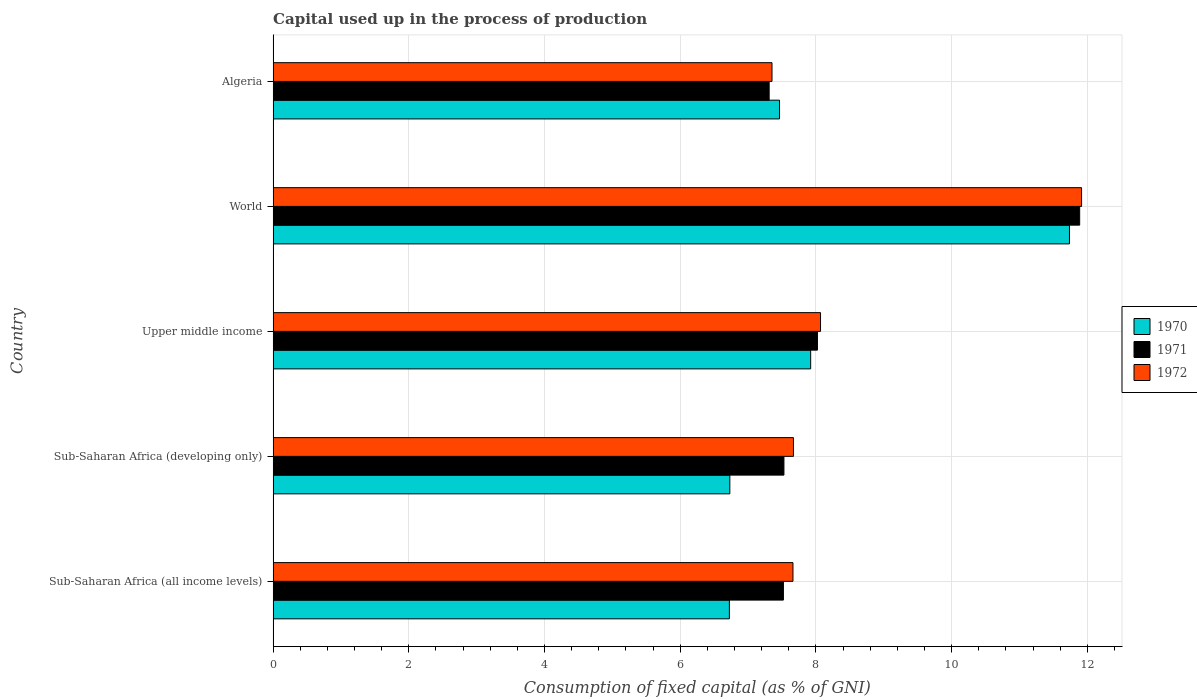How many different coloured bars are there?
Provide a short and direct response. 3. Are the number of bars on each tick of the Y-axis equal?
Your answer should be very brief. Yes. What is the label of the 5th group of bars from the top?
Keep it short and to the point. Sub-Saharan Africa (all income levels). In how many cases, is the number of bars for a given country not equal to the number of legend labels?
Your answer should be very brief. 0. What is the capital used up in the process of production in 1972 in Upper middle income?
Ensure brevity in your answer.  8.07. Across all countries, what is the maximum capital used up in the process of production in 1972?
Your response must be concise. 11.92. Across all countries, what is the minimum capital used up in the process of production in 1972?
Your response must be concise. 7.35. In which country was the capital used up in the process of production in 1970 maximum?
Offer a terse response. World. In which country was the capital used up in the process of production in 1972 minimum?
Your answer should be very brief. Algeria. What is the total capital used up in the process of production in 1972 in the graph?
Offer a terse response. 42.67. What is the difference between the capital used up in the process of production in 1971 in Sub-Saharan Africa (developing only) and that in World?
Your response must be concise. -4.36. What is the difference between the capital used up in the process of production in 1970 in Upper middle income and the capital used up in the process of production in 1971 in Sub-Saharan Africa (developing only)?
Give a very brief answer. 0.39. What is the average capital used up in the process of production in 1970 per country?
Your answer should be compact. 8.12. What is the difference between the capital used up in the process of production in 1970 and capital used up in the process of production in 1971 in Algeria?
Your response must be concise. 0.15. What is the ratio of the capital used up in the process of production in 1970 in Sub-Saharan Africa (all income levels) to that in World?
Ensure brevity in your answer.  0.57. Is the difference between the capital used up in the process of production in 1970 in Upper middle income and World greater than the difference between the capital used up in the process of production in 1971 in Upper middle income and World?
Offer a very short reply. Yes. What is the difference between the highest and the second highest capital used up in the process of production in 1971?
Give a very brief answer. 3.86. What is the difference between the highest and the lowest capital used up in the process of production in 1971?
Give a very brief answer. 4.58. Is the sum of the capital used up in the process of production in 1971 in Sub-Saharan Africa (all income levels) and World greater than the maximum capital used up in the process of production in 1972 across all countries?
Your answer should be very brief. Yes. What does the 2nd bar from the top in Upper middle income represents?
Provide a succinct answer. 1971. Does the graph contain grids?
Make the answer very short. Yes. How are the legend labels stacked?
Your answer should be very brief. Vertical. What is the title of the graph?
Give a very brief answer. Capital used up in the process of production. Does "1984" appear as one of the legend labels in the graph?
Your answer should be very brief. No. What is the label or title of the X-axis?
Ensure brevity in your answer.  Consumption of fixed capital (as % of GNI). What is the label or title of the Y-axis?
Make the answer very short. Country. What is the Consumption of fixed capital (as % of GNI) of 1970 in Sub-Saharan Africa (all income levels)?
Provide a short and direct response. 6.72. What is the Consumption of fixed capital (as % of GNI) in 1971 in Sub-Saharan Africa (all income levels)?
Provide a short and direct response. 7.52. What is the Consumption of fixed capital (as % of GNI) of 1972 in Sub-Saharan Africa (all income levels)?
Give a very brief answer. 7.66. What is the Consumption of fixed capital (as % of GNI) in 1970 in Sub-Saharan Africa (developing only)?
Make the answer very short. 6.73. What is the Consumption of fixed capital (as % of GNI) of 1971 in Sub-Saharan Africa (developing only)?
Your response must be concise. 7.53. What is the Consumption of fixed capital (as % of GNI) of 1972 in Sub-Saharan Africa (developing only)?
Provide a short and direct response. 7.67. What is the Consumption of fixed capital (as % of GNI) in 1970 in Upper middle income?
Provide a succinct answer. 7.92. What is the Consumption of fixed capital (as % of GNI) of 1971 in Upper middle income?
Your response must be concise. 8.02. What is the Consumption of fixed capital (as % of GNI) of 1972 in Upper middle income?
Your answer should be compact. 8.07. What is the Consumption of fixed capital (as % of GNI) in 1970 in World?
Provide a succinct answer. 11.74. What is the Consumption of fixed capital (as % of GNI) in 1971 in World?
Provide a succinct answer. 11.89. What is the Consumption of fixed capital (as % of GNI) of 1972 in World?
Ensure brevity in your answer.  11.92. What is the Consumption of fixed capital (as % of GNI) of 1970 in Algeria?
Offer a terse response. 7.46. What is the Consumption of fixed capital (as % of GNI) in 1971 in Algeria?
Offer a very short reply. 7.31. What is the Consumption of fixed capital (as % of GNI) in 1972 in Algeria?
Make the answer very short. 7.35. Across all countries, what is the maximum Consumption of fixed capital (as % of GNI) in 1970?
Provide a succinct answer. 11.74. Across all countries, what is the maximum Consumption of fixed capital (as % of GNI) of 1971?
Offer a terse response. 11.89. Across all countries, what is the maximum Consumption of fixed capital (as % of GNI) of 1972?
Provide a succinct answer. 11.92. Across all countries, what is the minimum Consumption of fixed capital (as % of GNI) in 1970?
Your answer should be very brief. 6.72. Across all countries, what is the minimum Consumption of fixed capital (as % of GNI) in 1971?
Make the answer very short. 7.31. Across all countries, what is the minimum Consumption of fixed capital (as % of GNI) of 1972?
Provide a short and direct response. 7.35. What is the total Consumption of fixed capital (as % of GNI) of 1970 in the graph?
Provide a succinct answer. 40.58. What is the total Consumption of fixed capital (as % of GNI) in 1971 in the graph?
Offer a very short reply. 42.27. What is the total Consumption of fixed capital (as % of GNI) in 1972 in the graph?
Give a very brief answer. 42.67. What is the difference between the Consumption of fixed capital (as % of GNI) of 1970 in Sub-Saharan Africa (all income levels) and that in Sub-Saharan Africa (developing only)?
Your response must be concise. -0.01. What is the difference between the Consumption of fixed capital (as % of GNI) of 1971 in Sub-Saharan Africa (all income levels) and that in Sub-Saharan Africa (developing only)?
Offer a terse response. -0.01. What is the difference between the Consumption of fixed capital (as % of GNI) of 1972 in Sub-Saharan Africa (all income levels) and that in Sub-Saharan Africa (developing only)?
Offer a terse response. -0.01. What is the difference between the Consumption of fixed capital (as % of GNI) of 1970 in Sub-Saharan Africa (all income levels) and that in Upper middle income?
Keep it short and to the point. -1.2. What is the difference between the Consumption of fixed capital (as % of GNI) in 1971 in Sub-Saharan Africa (all income levels) and that in Upper middle income?
Your answer should be very brief. -0.5. What is the difference between the Consumption of fixed capital (as % of GNI) of 1972 in Sub-Saharan Africa (all income levels) and that in Upper middle income?
Provide a succinct answer. -0.41. What is the difference between the Consumption of fixed capital (as % of GNI) in 1970 in Sub-Saharan Africa (all income levels) and that in World?
Give a very brief answer. -5.01. What is the difference between the Consumption of fixed capital (as % of GNI) of 1971 in Sub-Saharan Africa (all income levels) and that in World?
Offer a terse response. -4.37. What is the difference between the Consumption of fixed capital (as % of GNI) of 1972 in Sub-Saharan Africa (all income levels) and that in World?
Ensure brevity in your answer.  -4.25. What is the difference between the Consumption of fixed capital (as % of GNI) in 1970 in Sub-Saharan Africa (all income levels) and that in Algeria?
Offer a very short reply. -0.74. What is the difference between the Consumption of fixed capital (as % of GNI) in 1971 in Sub-Saharan Africa (all income levels) and that in Algeria?
Your answer should be compact. 0.21. What is the difference between the Consumption of fixed capital (as % of GNI) of 1972 in Sub-Saharan Africa (all income levels) and that in Algeria?
Ensure brevity in your answer.  0.31. What is the difference between the Consumption of fixed capital (as % of GNI) of 1970 in Sub-Saharan Africa (developing only) and that in Upper middle income?
Provide a short and direct response. -1.19. What is the difference between the Consumption of fixed capital (as % of GNI) of 1971 in Sub-Saharan Africa (developing only) and that in Upper middle income?
Your answer should be compact. -0.49. What is the difference between the Consumption of fixed capital (as % of GNI) in 1972 in Sub-Saharan Africa (developing only) and that in Upper middle income?
Your response must be concise. -0.4. What is the difference between the Consumption of fixed capital (as % of GNI) of 1970 in Sub-Saharan Africa (developing only) and that in World?
Your answer should be very brief. -5.01. What is the difference between the Consumption of fixed capital (as % of GNI) in 1971 in Sub-Saharan Africa (developing only) and that in World?
Your answer should be compact. -4.36. What is the difference between the Consumption of fixed capital (as % of GNI) of 1972 in Sub-Saharan Africa (developing only) and that in World?
Your answer should be very brief. -4.25. What is the difference between the Consumption of fixed capital (as % of GNI) in 1970 in Sub-Saharan Africa (developing only) and that in Algeria?
Offer a terse response. -0.73. What is the difference between the Consumption of fixed capital (as % of GNI) of 1971 in Sub-Saharan Africa (developing only) and that in Algeria?
Ensure brevity in your answer.  0.22. What is the difference between the Consumption of fixed capital (as % of GNI) in 1972 in Sub-Saharan Africa (developing only) and that in Algeria?
Make the answer very short. 0.32. What is the difference between the Consumption of fixed capital (as % of GNI) of 1970 in Upper middle income and that in World?
Your answer should be very brief. -3.81. What is the difference between the Consumption of fixed capital (as % of GNI) of 1971 in Upper middle income and that in World?
Provide a short and direct response. -3.86. What is the difference between the Consumption of fixed capital (as % of GNI) of 1972 in Upper middle income and that in World?
Your response must be concise. -3.85. What is the difference between the Consumption of fixed capital (as % of GNI) in 1970 in Upper middle income and that in Algeria?
Ensure brevity in your answer.  0.46. What is the difference between the Consumption of fixed capital (as % of GNI) in 1971 in Upper middle income and that in Algeria?
Offer a very short reply. 0.71. What is the difference between the Consumption of fixed capital (as % of GNI) in 1972 in Upper middle income and that in Algeria?
Your response must be concise. 0.72. What is the difference between the Consumption of fixed capital (as % of GNI) in 1970 in World and that in Algeria?
Your answer should be compact. 4.27. What is the difference between the Consumption of fixed capital (as % of GNI) of 1971 in World and that in Algeria?
Provide a short and direct response. 4.58. What is the difference between the Consumption of fixed capital (as % of GNI) of 1972 in World and that in Algeria?
Offer a terse response. 4.56. What is the difference between the Consumption of fixed capital (as % of GNI) in 1970 in Sub-Saharan Africa (all income levels) and the Consumption of fixed capital (as % of GNI) in 1971 in Sub-Saharan Africa (developing only)?
Provide a succinct answer. -0.8. What is the difference between the Consumption of fixed capital (as % of GNI) in 1970 in Sub-Saharan Africa (all income levels) and the Consumption of fixed capital (as % of GNI) in 1972 in Sub-Saharan Africa (developing only)?
Your answer should be very brief. -0.94. What is the difference between the Consumption of fixed capital (as % of GNI) in 1971 in Sub-Saharan Africa (all income levels) and the Consumption of fixed capital (as % of GNI) in 1972 in Sub-Saharan Africa (developing only)?
Give a very brief answer. -0.15. What is the difference between the Consumption of fixed capital (as % of GNI) of 1970 in Sub-Saharan Africa (all income levels) and the Consumption of fixed capital (as % of GNI) of 1971 in Upper middle income?
Make the answer very short. -1.3. What is the difference between the Consumption of fixed capital (as % of GNI) in 1970 in Sub-Saharan Africa (all income levels) and the Consumption of fixed capital (as % of GNI) in 1972 in Upper middle income?
Offer a terse response. -1.34. What is the difference between the Consumption of fixed capital (as % of GNI) in 1971 in Sub-Saharan Africa (all income levels) and the Consumption of fixed capital (as % of GNI) in 1972 in Upper middle income?
Ensure brevity in your answer.  -0.55. What is the difference between the Consumption of fixed capital (as % of GNI) in 1970 in Sub-Saharan Africa (all income levels) and the Consumption of fixed capital (as % of GNI) in 1971 in World?
Offer a terse response. -5.16. What is the difference between the Consumption of fixed capital (as % of GNI) of 1970 in Sub-Saharan Africa (all income levels) and the Consumption of fixed capital (as % of GNI) of 1972 in World?
Give a very brief answer. -5.19. What is the difference between the Consumption of fixed capital (as % of GNI) of 1971 in Sub-Saharan Africa (all income levels) and the Consumption of fixed capital (as % of GNI) of 1972 in World?
Your answer should be very brief. -4.39. What is the difference between the Consumption of fixed capital (as % of GNI) in 1970 in Sub-Saharan Africa (all income levels) and the Consumption of fixed capital (as % of GNI) in 1971 in Algeria?
Your answer should be very brief. -0.59. What is the difference between the Consumption of fixed capital (as % of GNI) in 1970 in Sub-Saharan Africa (all income levels) and the Consumption of fixed capital (as % of GNI) in 1972 in Algeria?
Ensure brevity in your answer.  -0.63. What is the difference between the Consumption of fixed capital (as % of GNI) of 1971 in Sub-Saharan Africa (all income levels) and the Consumption of fixed capital (as % of GNI) of 1972 in Algeria?
Your answer should be very brief. 0.17. What is the difference between the Consumption of fixed capital (as % of GNI) of 1970 in Sub-Saharan Africa (developing only) and the Consumption of fixed capital (as % of GNI) of 1971 in Upper middle income?
Your answer should be compact. -1.29. What is the difference between the Consumption of fixed capital (as % of GNI) in 1970 in Sub-Saharan Africa (developing only) and the Consumption of fixed capital (as % of GNI) in 1972 in Upper middle income?
Your answer should be compact. -1.34. What is the difference between the Consumption of fixed capital (as % of GNI) of 1971 in Sub-Saharan Africa (developing only) and the Consumption of fixed capital (as % of GNI) of 1972 in Upper middle income?
Provide a succinct answer. -0.54. What is the difference between the Consumption of fixed capital (as % of GNI) of 1970 in Sub-Saharan Africa (developing only) and the Consumption of fixed capital (as % of GNI) of 1971 in World?
Give a very brief answer. -5.16. What is the difference between the Consumption of fixed capital (as % of GNI) of 1970 in Sub-Saharan Africa (developing only) and the Consumption of fixed capital (as % of GNI) of 1972 in World?
Give a very brief answer. -5.18. What is the difference between the Consumption of fixed capital (as % of GNI) in 1971 in Sub-Saharan Africa (developing only) and the Consumption of fixed capital (as % of GNI) in 1972 in World?
Your response must be concise. -4.39. What is the difference between the Consumption of fixed capital (as % of GNI) in 1970 in Sub-Saharan Africa (developing only) and the Consumption of fixed capital (as % of GNI) in 1971 in Algeria?
Your answer should be compact. -0.58. What is the difference between the Consumption of fixed capital (as % of GNI) in 1970 in Sub-Saharan Africa (developing only) and the Consumption of fixed capital (as % of GNI) in 1972 in Algeria?
Keep it short and to the point. -0.62. What is the difference between the Consumption of fixed capital (as % of GNI) of 1971 in Sub-Saharan Africa (developing only) and the Consumption of fixed capital (as % of GNI) of 1972 in Algeria?
Make the answer very short. 0.18. What is the difference between the Consumption of fixed capital (as % of GNI) of 1970 in Upper middle income and the Consumption of fixed capital (as % of GNI) of 1971 in World?
Provide a succinct answer. -3.96. What is the difference between the Consumption of fixed capital (as % of GNI) of 1970 in Upper middle income and the Consumption of fixed capital (as % of GNI) of 1972 in World?
Give a very brief answer. -3.99. What is the difference between the Consumption of fixed capital (as % of GNI) of 1971 in Upper middle income and the Consumption of fixed capital (as % of GNI) of 1972 in World?
Give a very brief answer. -3.89. What is the difference between the Consumption of fixed capital (as % of GNI) of 1970 in Upper middle income and the Consumption of fixed capital (as % of GNI) of 1971 in Algeria?
Ensure brevity in your answer.  0.61. What is the difference between the Consumption of fixed capital (as % of GNI) of 1970 in Upper middle income and the Consumption of fixed capital (as % of GNI) of 1972 in Algeria?
Your response must be concise. 0.57. What is the difference between the Consumption of fixed capital (as % of GNI) of 1971 in Upper middle income and the Consumption of fixed capital (as % of GNI) of 1972 in Algeria?
Give a very brief answer. 0.67. What is the difference between the Consumption of fixed capital (as % of GNI) of 1970 in World and the Consumption of fixed capital (as % of GNI) of 1971 in Algeria?
Make the answer very short. 4.43. What is the difference between the Consumption of fixed capital (as % of GNI) in 1970 in World and the Consumption of fixed capital (as % of GNI) in 1972 in Algeria?
Keep it short and to the point. 4.38. What is the difference between the Consumption of fixed capital (as % of GNI) of 1971 in World and the Consumption of fixed capital (as % of GNI) of 1972 in Algeria?
Give a very brief answer. 4.53. What is the average Consumption of fixed capital (as % of GNI) of 1970 per country?
Make the answer very short. 8.12. What is the average Consumption of fixed capital (as % of GNI) of 1971 per country?
Provide a short and direct response. 8.45. What is the average Consumption of fixed capital (as % of GNI) of 1972 per country?
Provide a succinct answer. 8.53. What is the difference between the Consumption of fixed capital (as % of GNI) of 1970 and Consumption of fixed capital (as % of GNI) of 1971 in Sub-Saharan Africa (all income levels)?
Offer a very short reply. -0.8. What is the difference between the Consumption of fixed capital (as % of GNI) in 1970 and Consumption of fixed capital (as % of GNI) in 1972 in Sub-Saharan Africa (all income levels)?
Provide a succinct answer. -0.94. What is the difference between the Consumption of fixed capital (as % of GNI) of 1971 and Consumption of fixed capital (as % of GNI) of 1972 in Sub-Saharan Africa (all income levels)?
Offer a terse response. -0.14. What is the difference between the Consumption of fixed capital (as % of GNI) of 1970 and Consumption of fixed capital (as % of GNI) of 1971 in Sub-Saharan Africa (developing only)?
Provide a succinct answer. -0.8. What is the difference between the Consumption of fixed capital (as % of GNI) of 1970 and Consumption of fixed capital (as % of GNI) of 1972 in Sub-Saharan Africa (developing only)?
Ensure brevity in your answer.  -0.94. What is the difference between the Consumption of fixed capital (as % of GNI) of 1971 and Consumption of fixed capital (as % of GNI) of 1972 in Sub-Saharan Africa (developing only)?
Offer a terse response. -0.14. What is the difference between the Consumption of fixed capital (as % of GNI) of 1970 and Consumption of fixed capital (as % of GNI) of 1971 in Upper middle income?
Ensure brevity in your answer.  -0.1. What is the difference between the Consumption of fixed capital (as % of GNI) in 1970 and Consumption of fixed capital (as % of GNI) in 1972 in Upper middle income?
Make the answer very short. -0.15. What is the difference between the Consumption of fixed capital (as % of GNI) in 1971 and Consumption of fixed capital (as % of GNI) in 1972 in Upper middle income?
Offer a terse response. -0.05. What is the difference between the Consumption of fixed capital (as % of GNI) in 1970 and Consumption of fixed capital (as % of GNI) in 1971 in World?
Your response must be concise. -0.15. What is the difference between the Consumption of fixed capital (as % of GNI) of 1970 and Consumption of fixed capital (as % of GNI) of 1972 in World?
Ensure brevity in your answer.  -0.18. What is the difference between the Consumption of fixed capital (as % of GNI) of 1971 and Consumption of fixed capital (as % of GNI) of 1972 in World?
Offer a terse response. -0.03. What is the difference between the Consumption of fixed capital (as % of GNI) of 1970 and Consumption of fixed capital (as % of GNI) of 1971 in Algeria?
Your answer should be very brief. 0.15. What is the difference between the Consumption of fixed capital (as % of GNI) in 1971 and Consumption of fixed capital (as % of GNI) in 1972 in Algeria?
Provide a succinct answer. -0.04. What is the ratio of the Consumption of fixed capital (as % of GNI) of 1971 in Sub-Saharan Africa (all income levels) to that in Sub-Saharan Africa (developing only)?
Your response must be concise. 1. What is the ratio of the Consumption of fixed capital (as % of GNI) of 1972 in Sub-Saharan Africa (all income levels) to that in Sub-Saharan Africa (developing only)?
Provide a succinct answer. 1. What is the ratio of the Consumption of fixed capital (as % of GNI) of 1970 in Sub-Saharan Africa (all income levels) to that in Upper middle income?
Offer a terse response. 0.85. What is the ratio of the Consumption of fixed capital (as % of GNI) of 1971 in Sub-Saharan Africa (all income levels) to that in Upper middle income?
Make the answer very short. 0.94. What is the ratio of the Consumption of fixed capital (as % of GNI) in 1972 in Sub-Saharan Africa (all income levels) to that in Upper middle income?
Make the answer very short. 0.95. What is the ratio of the Consumption of fixed capital (as % of GNI) of 1970 in Sub-Saharan Africa (all income levels) to that in World?
Ensure brevity in your answer.  0.57. What is the ratio of the Consumption of fixed capital (as % of GNI) of 1971 in Sub-Saharan Africa (all income levels) to that in World?
Make the answer very short. 0.63. What is the ratio of the Consumption of fixed capital (as % of GNI) of 1972 in Sub-Saharan Africa (all income levels) to that in World?
Give a very brief answer. 0.64. What is the ratio of the Consumption of fixed capital (as % of GNI) of 1970 in Sub-Saharan Africa (all income levels) to that in Algeria?
Offer a very short reply. 0.9. What is the ratio of the Consumption of fixed capital (as % of GNI) of 1971 in Sub-Saharan Africa (all income levels) to that in Algeria?
Provide a succinct answer. 1.03. What is the ratio of the Consumption of fixed capital (as % of GNI) in 1972 in Sub-Saharan Africa (all income levels) to that in Algeria?
Your response must be concise. 1.04. What is the ratio of the Consumption of fixed capital (as % of GNI) in 1970 in Sub-Saharan Africa (developing only) to that in Upper middle income?
Your answer should be very brief. 0.85. What is the ratio of the Consumption of fixed capital (as % of GNI) in 1971 in Sub-Saharan Africa (developing only) to that in Upper middle income?
Your answer should be compact. 0.94. What is the ratio of the Consumption of fixed capital (as % of GNI) of 1972 in Sub-Saharan Africa (developing only) to that in Upper middle income?
Keep it short and to the point. 0.95. What is the ratio of the Consumption of fixed capital (as % of GNI) in 1970 in Sub-Saharan Africa (developing only) to that in World?
Ensure brevity in your answer.  0.57. What is the ratio of the Consumption of fixed capital (as % of GNI) of 1971 in Sub-Saharan Africa (developing only) to that in World?
Provide a succinct answer. 0.63. What is the ratio of the Consumption of fixed capital (as % of GNI) in 1972 in Sub-Saharan Africa (developing only) to that in World?
Your answer should be compact. 0.64. What is the ratio of the Consumption of fixed capital (as % of GNI) in 1970 in Sub-Saharan Africa (developing only) to that in Algeria?
Offer a very short reply. 0.9. What is the ratio of the Consumption of fixed capital (as % of GNI) in 1971 in Sub-Saharan Africa (developing only) to that in Algeria?
Provide a succinct answer. 1.03. What is the ratio of the Consumption of fixed capital (as % of GNI) in 1972 in Sub-Saharan Africa (developing only) to that in Algeria?
Your answer should be very brief. 1.04. What is the ratio of the Consumption of fixed capital (as % of GNI) of 1970 in Upper middle income to that in World?
Offer a terse response. 0.68. What is the ratio of the Consumption of fixed capital (as % of GNI) in 1971 in Upper middle income to that in World?
Your answer should be very brief. 0.67. What is the ratio of the Consumption of fixed capital (as % of GNI) in 1972 in Upper middle income to that in World?
Offer a very short reply. 0.68. What is the ratio of the Consumption of fixed capital (as % of GNI) in 1970 in Upper middle income to that in Algeria?
Offer a very short reply. 1.06. What is the ratio of the Consumption of fixed capital (as % of GNI) in 1971 in Upper middle income to that in Algeria?
Make the answer very short. 1.1. What is the ratio of the Consumption of fixed capital (as % of GNI) of 1972 in Upper middle income to that in Algeria?
Make the answer very short. 1.1. What is the ratio of the Consumption of fixed capital (as % of GNI) in 1970 in World to that in Algeria?
Offer a terse response. 1.57. What is the ratio of the Consumption of fixed capital (as % of GNI) in 1971 in World to that in Algeria?
Give a very brief answer. 1.63. What is the ratio of the Consumption of fixed capital (as % of GNI) of 1972 in World to that in Algeria?
Offer a very short reply. 1.62. What is the difference between the highest and the second highest Consumption of fixed capital (as % of GNI) of 1970?
Give a very brief answer. 3.81. What is the difference between the highest and the second highest Consumption of fixed capital (as % of GNI) in 1971?
Your response must be concise. 3.86. What is the difference between the highest and the second highest Consumption of fixed capital (as % of GNI) of 1972?
Your response must be concise. 3.85. What is the difference between the highest and the lowest Consumption of fixed capital (as % of GNI) in 1970?
Your response must be concise. 5.01. What is the difference between the highest and the lowest Consumption of fixed capital (as % of GNI) of 1971?
Your answer should be very brief. 4.58. What is the difference between the highest and the lowest Consumption of fixed capital (as % of GNI) of 1972?
Keep it short and to the point. 4.56. 